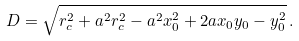Convert formula to latex. <formula><loc_0><loc_0><loc_500><loc_500>D & = \sqrt { r _ { c } ^ { 2 } + a ^ { 2 } r _ { c } ^ { 2 } - a ^ { 2 } x _ { 0 } ^ { 2 } + 2 a x _ { 0 } y _ { 0 } - y _ { 0 } ^ { 2 } } \, .</formula> 